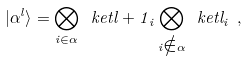<formula> <loc_0><loc_0><loc_500><loc_500>| \alpha ^ { l } \rangle = \bigotimes _ { i \in \alpha } \ k e t { l + 1 } _ { i } \bigotimes _ { i \notin \alpha } \ k e t { l } _ { i } \ ,</formula> 